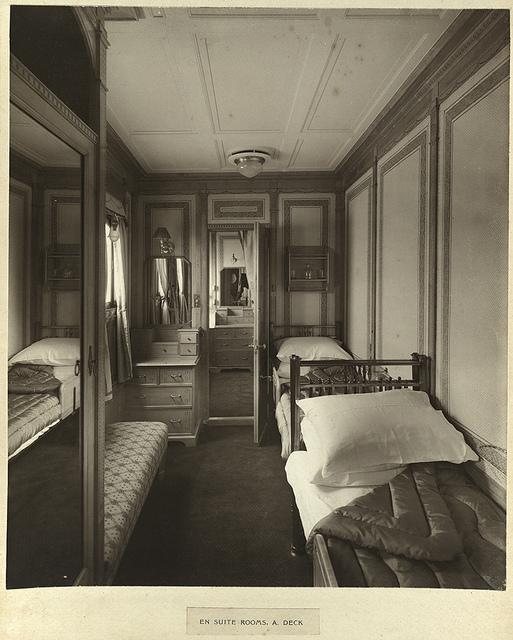Where is the mirror located?
Concise answer only. Above dresser. Are there pillows on the bed?
Quick response, please. Yes. What kind of room is this?
Be succinct. Bedroom. 